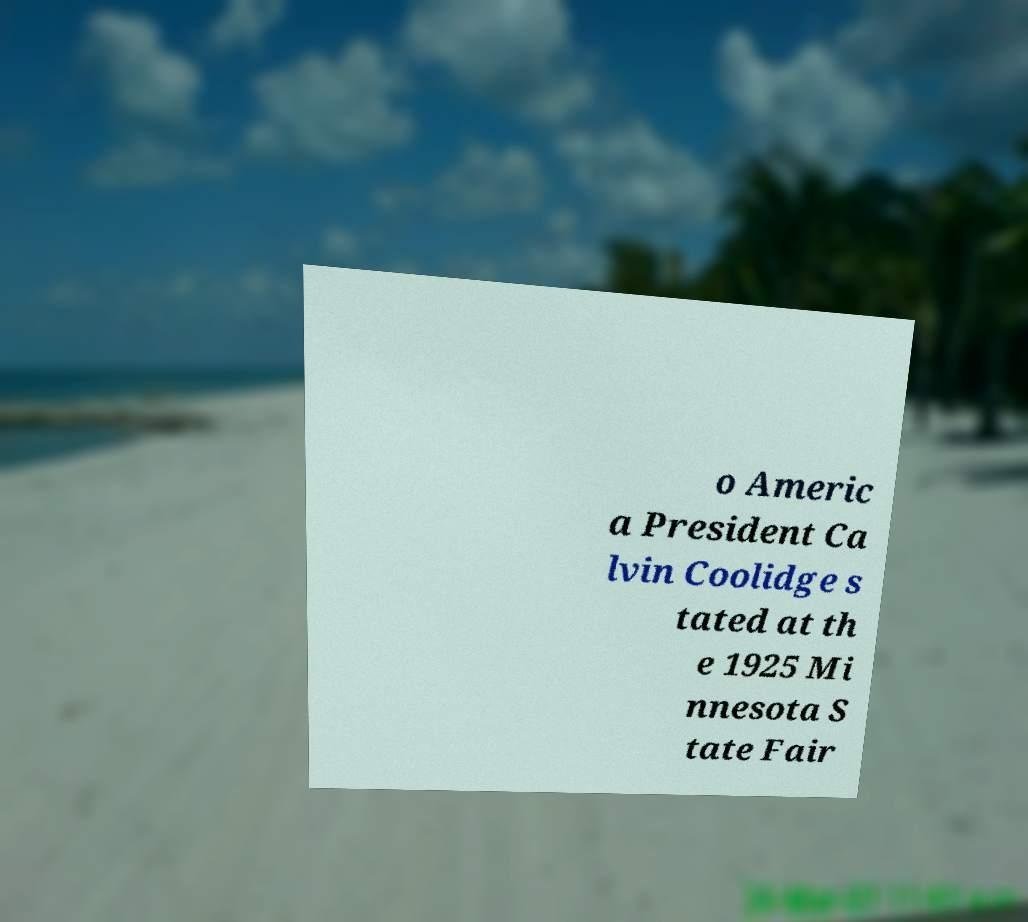For documentation purposes, I need the text within this image transcribed. Could you provide that? o Americ a President Ca lvin Coolidge s tated at th e 1925 Mi nnesota S tate Fair 